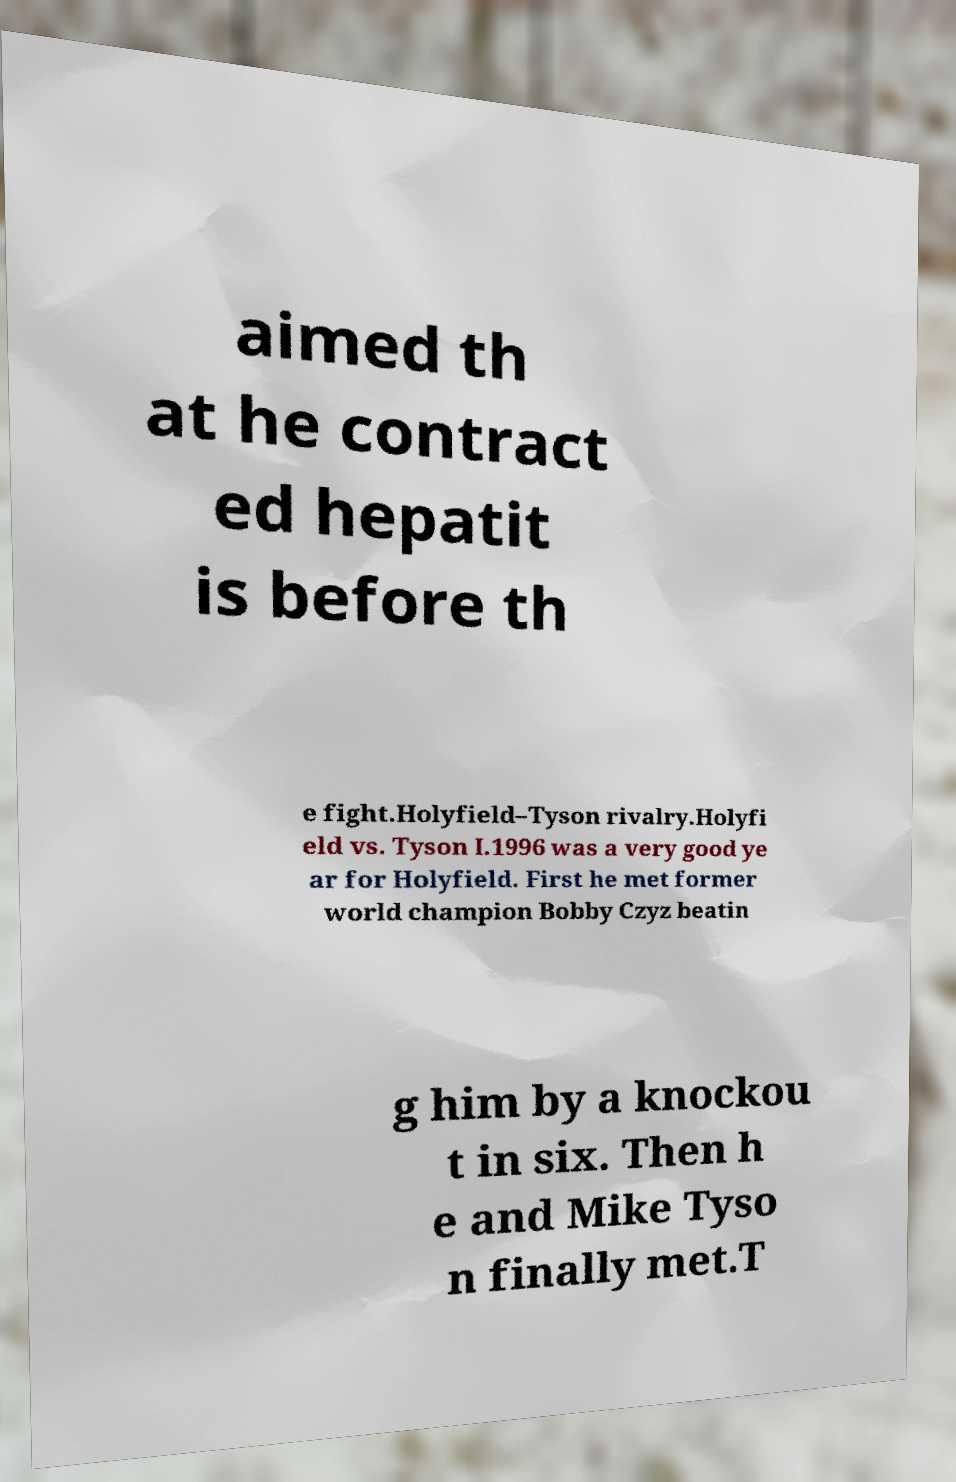Could you assist in decoding the text presented in this image and type it out clearly? aimed th at he contract ed hepatit is before th e fight.Holyfield–Tyson rivalry.Holyfi eld vs. Tyson I.1996 was a very good ye ar for Holyfield. First he met former world champion Bobby Czyz beatin g him by a knockou t in six. Then h e and Mike Tyso n finally met.T 